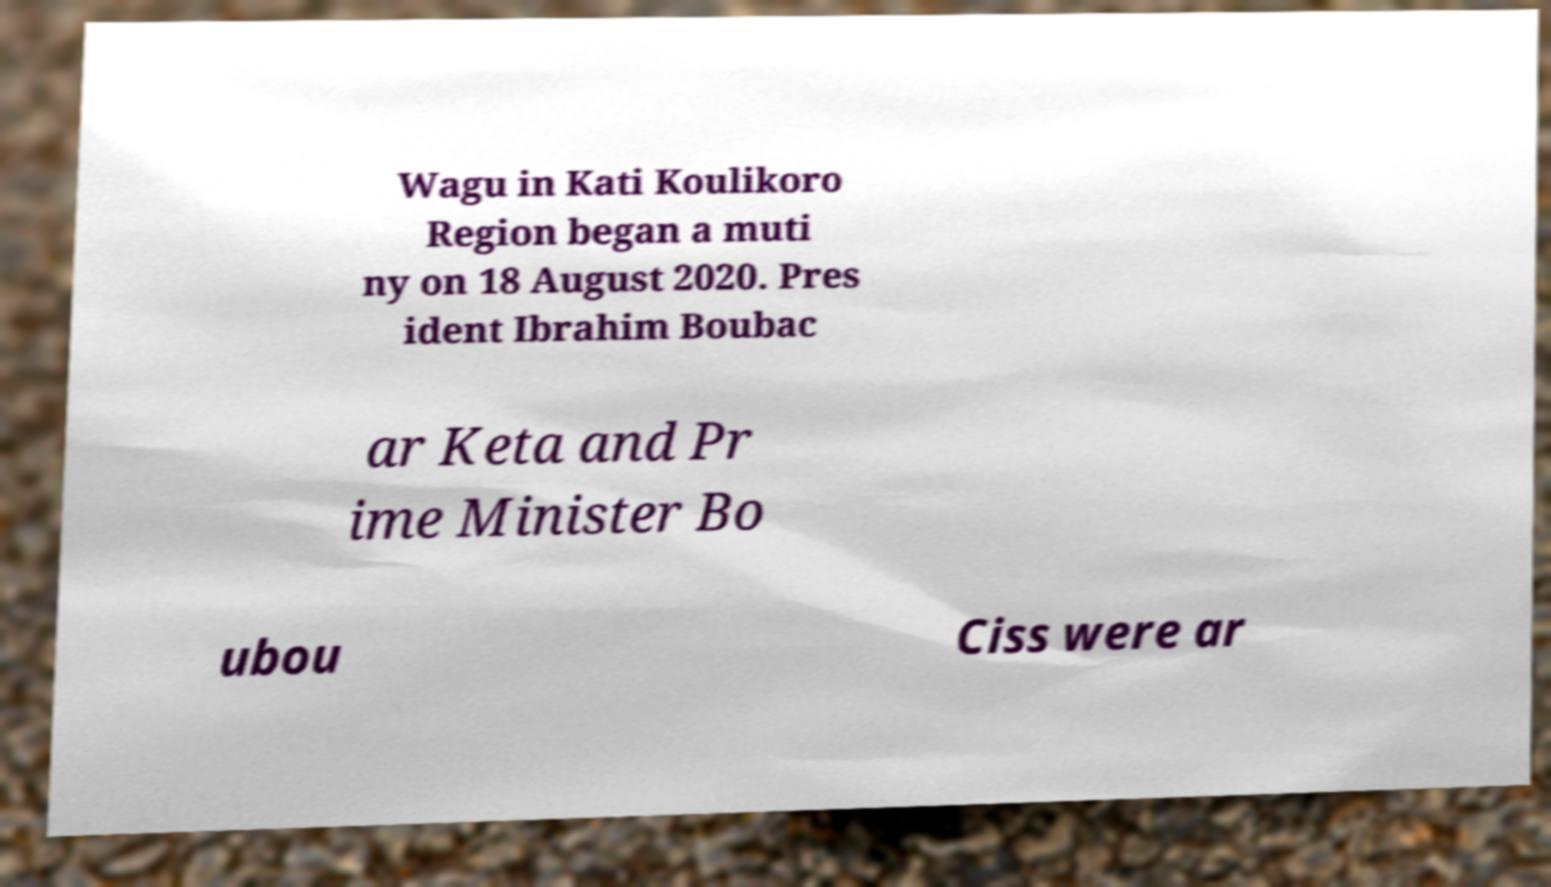There's text embedded in this image that I need extracted. Can you transcribe it verbatim? Wagu in Kati Koulikoro Region began a muti ny on 18 August 2020. Pres ident Ibrahim Boubac ar Keta and Pr ime Minister Bo ubou Ciss were ar 